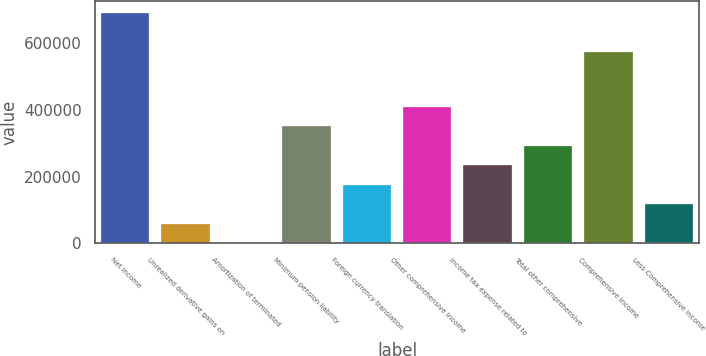<chart> <loc_0><loc_0><loc_500><loc_500><bar_chart><fcel>Net income<fcel>Unrealized derivative gains on<fcel>Amortization of terminated<fcel>Minimum pension liability<fcel>Foreign currency translation<fcel>Other comprehensive income<fcel>Income tax expense related to<fcel>Total other comprehensive<fcel>Comprehensive income<fcel>Less Comprehensive income<nl><fcel>691170<fcel>58543.5<fcel>0.67<fcel>351258<fcel>175629<fcel>409800<fcel>234172<fcel>292715<fcel>574084<fcel>117086<nl></chart> 